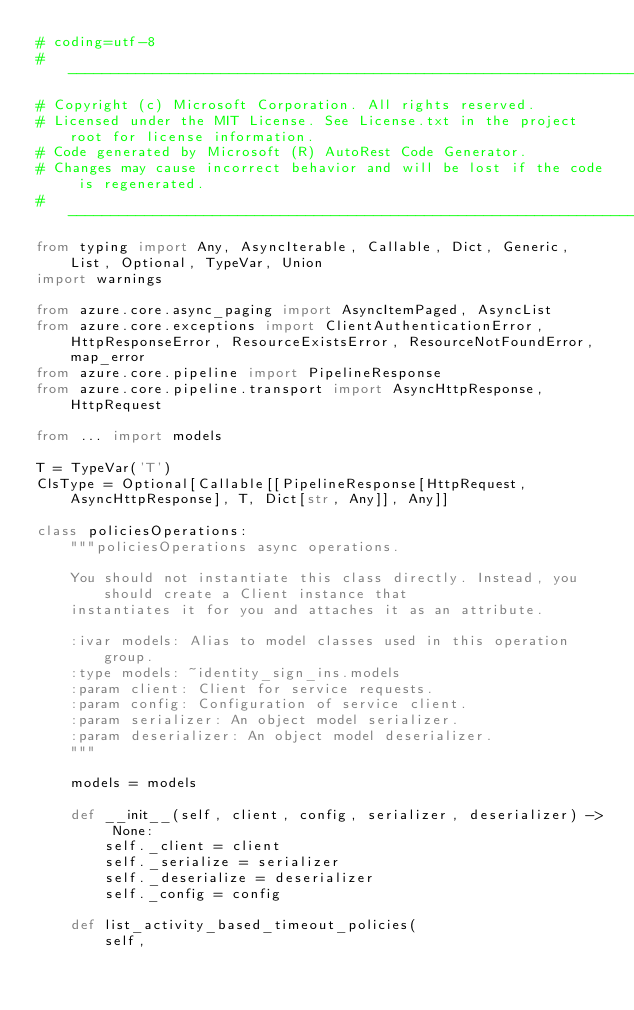Convert code to text. <code><loc_0><loc_0><loc_500><loc_500><_Python_># coding=utf-8
# --------------------------------------------------------------------------
# Copyright (c) Microsoft Corporation. All rights reserved.
# Licensed under the MIT License. See License.txt in the project root for license information.
# Code generated by Microsoft (R) AutoRest Code Generator.
# Changes may cause incorrect behavior and will be lost if the code is regenerated.
# --------------------------------------------------------------------------
from typing import Any, AsyncIterable, Callable, Dict, Generic, List, Optional, TypeVar, Union
import warnings

from azure.core.async_paging import AsyncItemPaged, AsyncList
from azure.core.exceptions import ClientAuthenticationError, HttpResponseError, ResourceExistsError, ResourceNotFoundError, map_error
from azure.core.pipeline import PipelineResponse
from azure.core.pipeline.transport import AsyncHttpResponse, HttpRequest

from ... import models

T = TypeVar('T')
ClsType = Optional[Callable[[PipelineResponse[HttpRequest, AsyncHttpResponse], T, Dict[str, Any]], Any]]

class policiesOperations:
    """policiesOperations async operations.

    You should not instantiate this class directly. Instead, you should create a Client instance that
    instantiates it for you and attaches it as an attribute.

    :ivar models: Alias to model classes used in this operation group.
    :type models: ~identity_sign_ins.models
    :param client: Client for service requests.
    :param config: Configuration of service client.
    :param serializer: An object model serializer.
    :param deserializer: An object model deserializer.
    """

    models = models

    def __init__(self, client, config, serializer, deserializer) -> None:
        self._client = client
        self._serialize = serializer
        self._deserialize = deserializer
        self._config = config

    def list_activity_based_timeout_policies(
        self,</code> 